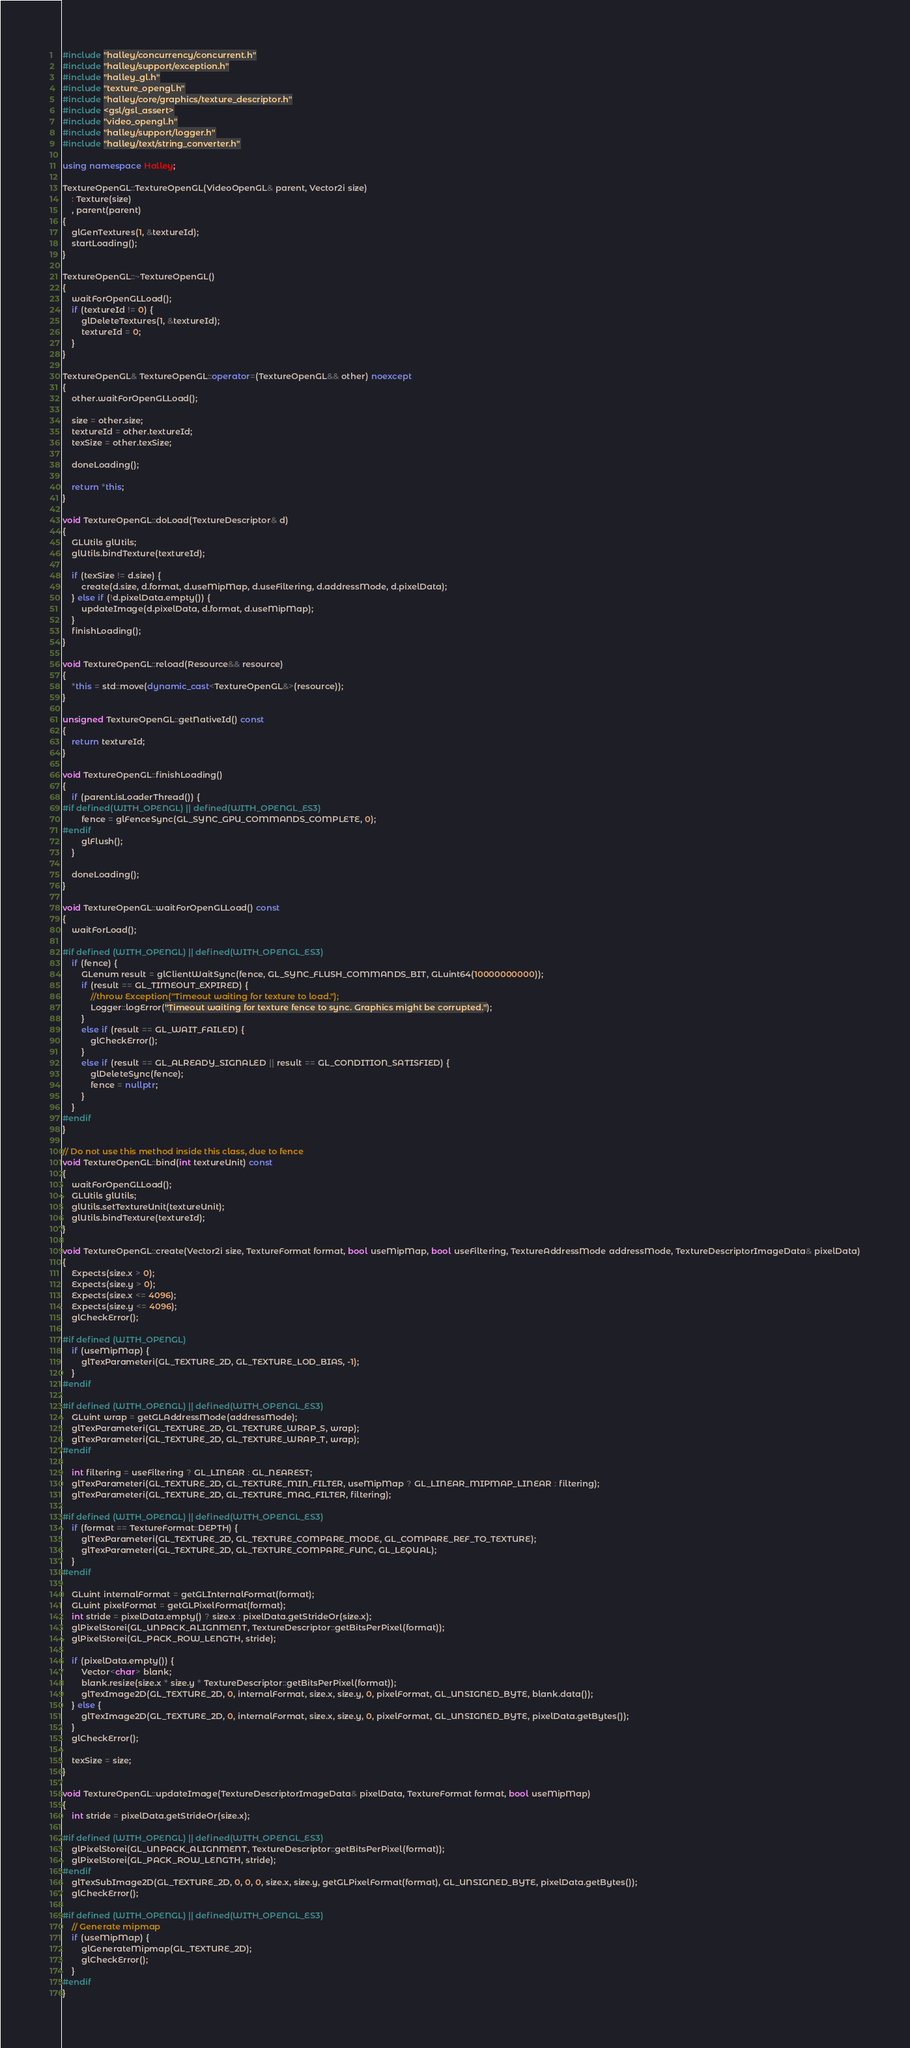Convert code to text. <code><loc_0><loc_0><loc_500><loc_500><_C++_>#include "halley/concurrency/concurrent.h"
#include "halley/support/exception.h"
#include "halley_gl.h"
#include "texture_opengl.h"
#include "halley/core/graphics/texture_descriptor.h"
#include <gsl/gsl_assert>
#include "video_opengl.h"
#include "halley/support/logger.h"
#include "halley/text/string_converter.h"

using namespace Halley;

TextureOpenGL::TextureOpenGL(VideoOpenGL& parent, Vector2i size)
	: Texture(size)
	, parent(parent)
{
	glGenTextures(1, &textureId);
	startLoading();
}

TextureOpenGL::~TextureOpenGL()
{
	waitForOpenGLLoad();
	if (textureId != 0) {
		glDeleteTextures(1, &textureId);
		textureId = 0;
	}
}

TextureOpenGL& TextureOpenGL::operator=(TextureOpenGL&& other) noexcept
{
	other.waitForOpenGLLoad();

	size = other.size;
	textureId = other.textureId;
	texSize = other.texSize;

	doneLoading();

	return *this;
}

void TextureOpenGL::doLoad(TextureDescriptor& d)
{
	GLUtils glUtils;
	glUtils.bindTexture(textureId);
	
	if (texSize != d.size) {
		create(d.size, d.format, d.useMipMap, d.useFiltering, d.addressMode, d.pixelData);
	} else if (!d.pixelData.empty()) {
		updateImage(d.pixelData, d.format, d.useMipMap);
	}
	finishLoading();
}

void TextureOpenGL::reload(Resource&& resource)
{
	*this = std::move(dynamic_cast<TextureOpenGL&>(resource));
}

unsigned TextureOpenGL::getNativeId() const
{
	return textureId;
}

void TextureOpenGL::finishLoading()
{
	if (parent.isLoaderThread()) {
#if defined(WITH_OPENGL) || defined(WITH_OPENGL_ES3)
		fence = glFenceSync(GL_SYNC_GPU_COMMANDS_COMPLETE, 0);
#endif
		glFlush();
	}

	doneLoading();
}

void TextureOpenGL::waitForOpenGLLoad() const
{
	waitForLoad();

#if defined (WITH_OPENGL) || defined(WITH_OPENGL_ES3)
	if (fence) {
		GLenum result = glClientWaitSync(fence, GL_SYNC_FLUSH_COMMANDS_BIT, GLuint64(10000000000));
		if (result == GL_TIMEOUT_EXPIRED) {
			//throw Exception("Timeout waiting for texture to load.");
			Logger::logError("Timeout waiting for texture fence to sync. Graphics might be corrupted.");
		}
		else if (result == GL_WAIT_FAILED) {
			glCheckError();
		}
		else if (result == GL_ALREADY_SIGNALED || result == GL_CONDITION_SATISFIED) {
			glDeleteSync(fence);
			fence = nullptr;
		}
	}
#endif
}

// Do not use this method inside this class, due to fence
void TextureOpenGL::bind(int textureUnit) const
{
	waitForOpenGLLoad();
	GLUtils glUtils;
	glUtils.setTextureUnit(textureUnit);
	glUtils.bindTexture(textureId);
}

void TextureOpenGL::create(Vector2i size, TextureFormat format, bool useMipMap, bool useFiltering, TextureAddressMode addressMode, TextureDescriptorImageData& pixelData)
{
	Expects(size.x > 0);
	Expects(size.y > 0);
	Expects(size.x <= 4096);
	Expects(size.y <= 4096);
	glCheckError();

#if defined (WITH_OPENGL)
	if (useMipMap) {
		glTexParameteri(GL_TEXTURE_2D, GL_TEXTURE_LOD_BIAS, -1);
	}
#endif

#if defined (WITH_OPENGL) || defined(WITH_OPENGL_ES3)
	GLuint wrap = getGLAddressMode(addressMode);
	glTexParameteri(GL_TEXTURE_2D, GL_TEXTURE_WRAP_S, wrap);
	glTexParameteri(GL_TEXTURE_2D, GL_TEXTURE_WRAP_T, wrap);
#endif

	int filtering = useFiltering ? GL_LINEAR : GL_NEAREST;
	glTexParameteri(GL_TEXTURE_2D, GL_TEXTURE_MIN_FILTER, useMipMap ? GL_LINEAR_MIPMAP_LINEAR : filtering);
	glTexParameteri(GL_TEXTURE_2D, GL_TEXTURE_MAG_FILTER, filtering);

#if defined (WITH_OPENGL) || defined(WITH_OPENGL_ES3)
	if (format == TextureFormat::DEPTH) {
		glTexParameteri(GL_TEXTURE_2D, GL_TEXTURE_COMPARE_MODE, GL_COMPARE_REF_TO_TEXTURE);
		glTexParameteri(GL_TEXTURE_2D, GL_TEXTURE_COMPARE_FUNC, GL_LEQUAL);
	}
#endif

	GLuint internalFormat = getGLInternalFormat(format);
	GLuint pixelFormat = getGLPixelFormat(format);
	int stride = pixelData.empty() ? size.x : pixelData.getStrideOr(size.x);
	glPixelStorei(GL_UNPACK_ALIGNMENT, TextureDescriptor::getBitsPerPixel(format));
	glPixelStorei(GL_PACK_ROW_LENGTH, stride);

	if (pixelData.empty()) {
		Vector<char> blank;
		blank.resize(size.x * size.y * TextureDescriptor::getBitsPerPixel(format));
		glTexImage2D(GL_TEXTURE_2D, 0, internalFormat, size.x, size.y, 0, pixelFormat, GL_UNSIGNED_BYTE, blank.data());
	} else {
		glTexImage2D(GL_TEXTURE_2D, 0, internalFormat, size.x, size.y, 0, pixelFormat, GL_UNSIGNED_BYTE, pixelData.getBytes());
	}
	glCheckError();

	texSize = size;
}

void TextureOpenGL::updateImage(TextureDescriptorImageData& pixelData, TextureFormat format, bool useMipMap)
{
	int stride = pixelData.getStrideOr(size.x);

#if defined (WITH_OPENGL) || defined(WITH_OPENGL_ES3)
	glPixelStorei(GL_UNPACK_ALIGNMENT, TextureDescriptor::getBitsPerPixel(format));
	glPixelStorei(GL_PACK_ROW_LENGTH, stride);
#endif
	glTexSubImage2D(GL_TEXTURE_2D, 0, 0, 0, size.x, size.y, getGLPixelFormat(format), GL_UNSIGNED_BYTE, pixelData.getBytes());
	glCheckError();

#if defined (WITH_OPENGL) || defined(WITH_OPENGL_ES3)
	// Generate mipmap
	if (useMipMap) {
		glGenerateMipmap(GL_TEXTURE_2D);
		glCheckError();
	}
#endif
}
</code> 